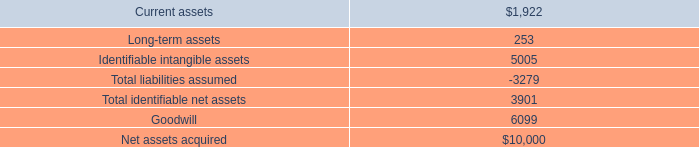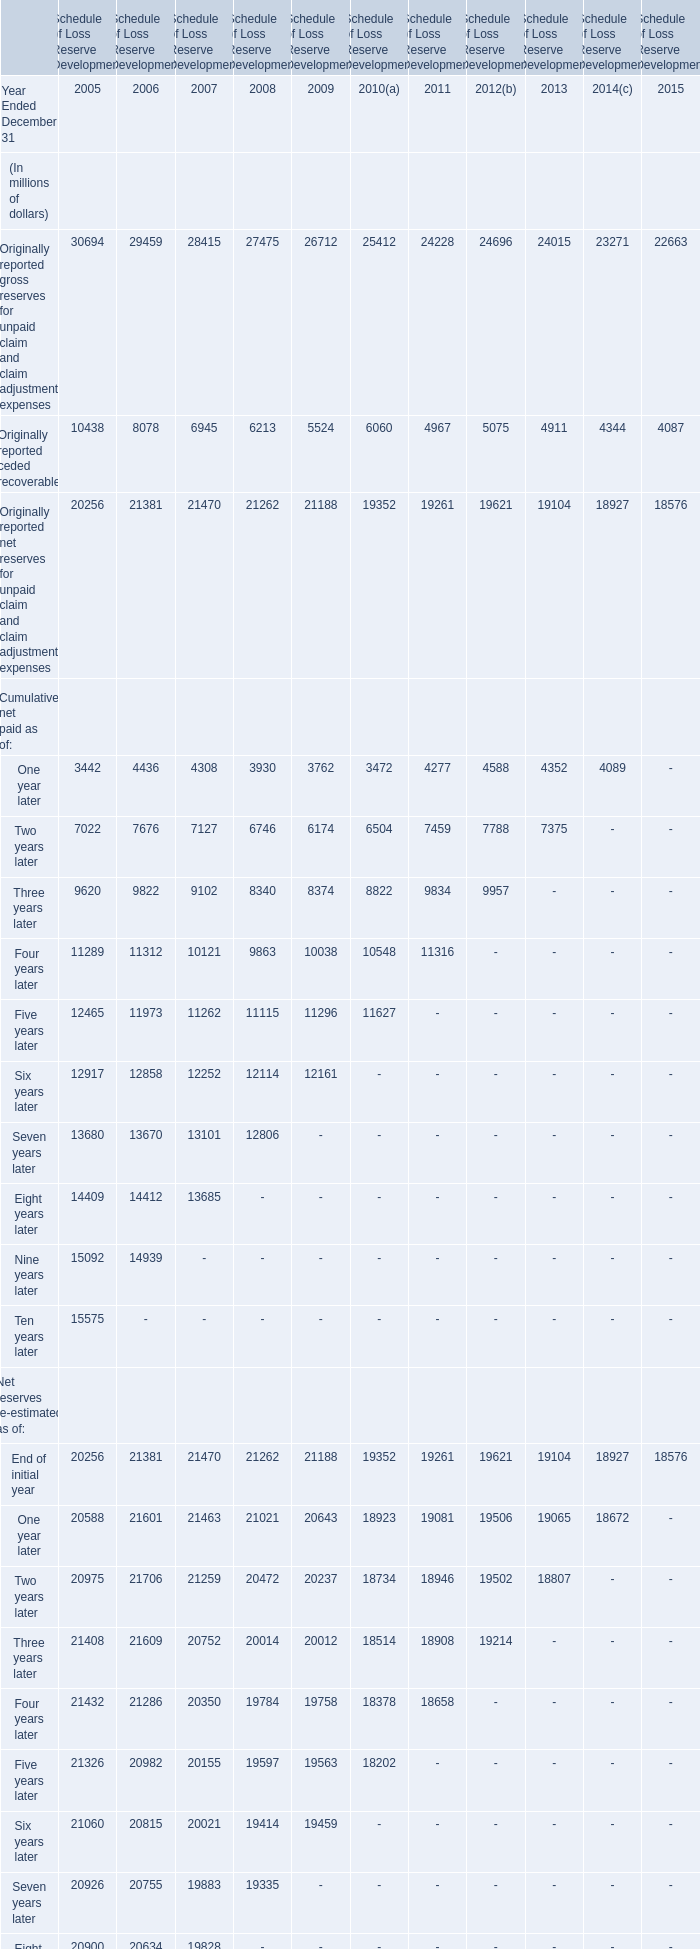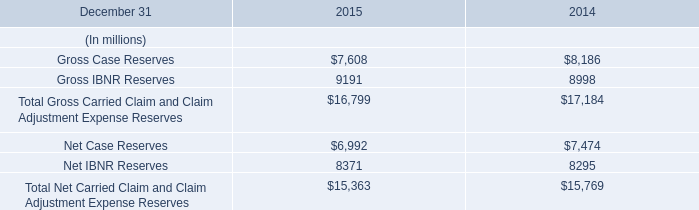What will the amount for originally reported ceded recoverable be like in 2016 if it develops with the same growth rate as current? (in million) 
Computations: (4087 * (1 + ((4087 - 4344) / 4344)))
Answer: 3845.20465. 